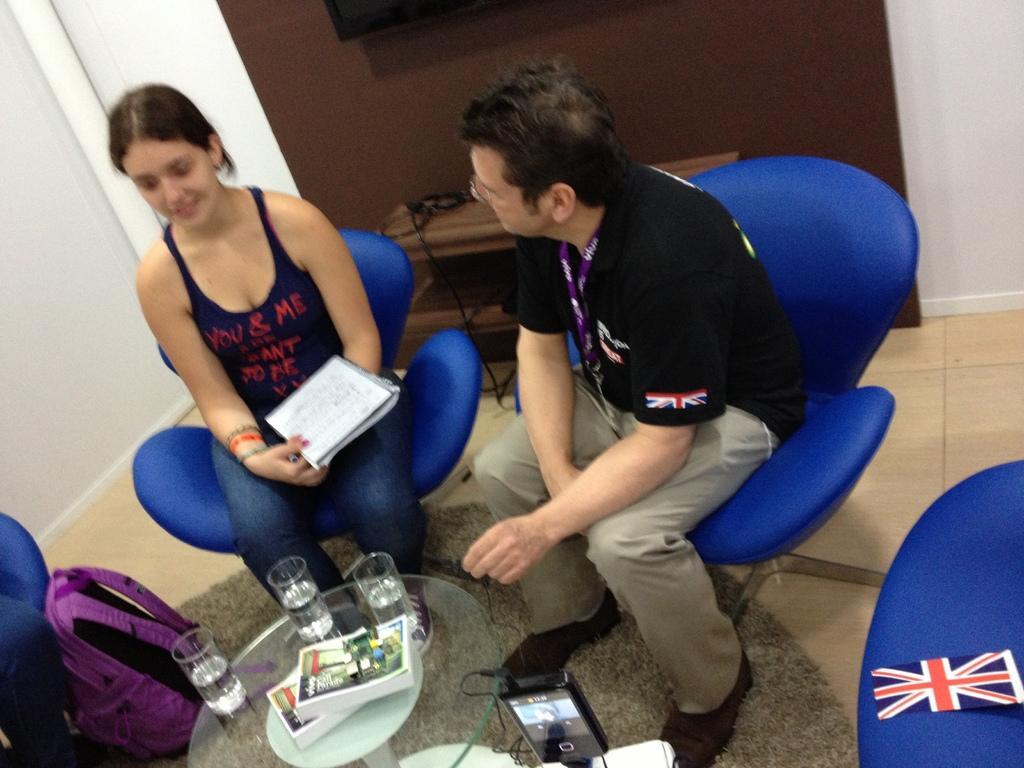Please provide a concise description of this image. In this picture there is a table at the bottom side of the image, which contains glasses and books on it, there is a bag on the floor, there is a man and a woman on the chairs and there is a television at the top side of the image. 